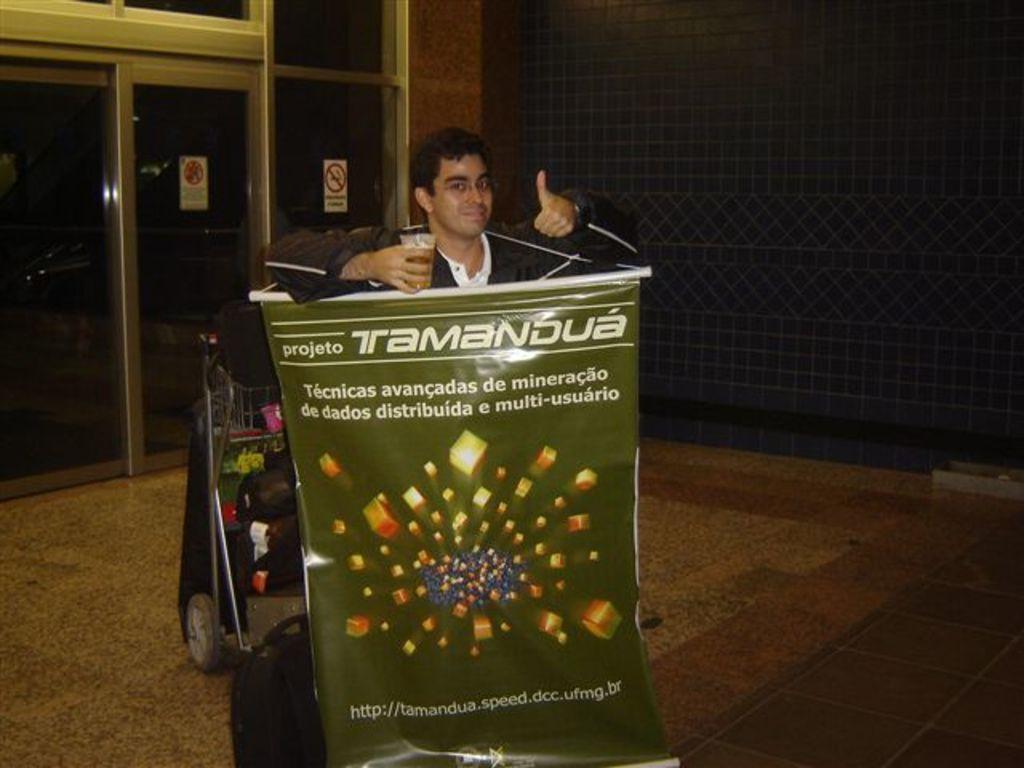How would you summarize this image in a sentence or two? In this picture there is a man standing and holding the glass. In the foreground there is a banner, there is text on the banner. At the back there is a bag and there are objects in the trolley. There are posters on the glass, there is text on the posters. At the bottom there is a floor. 